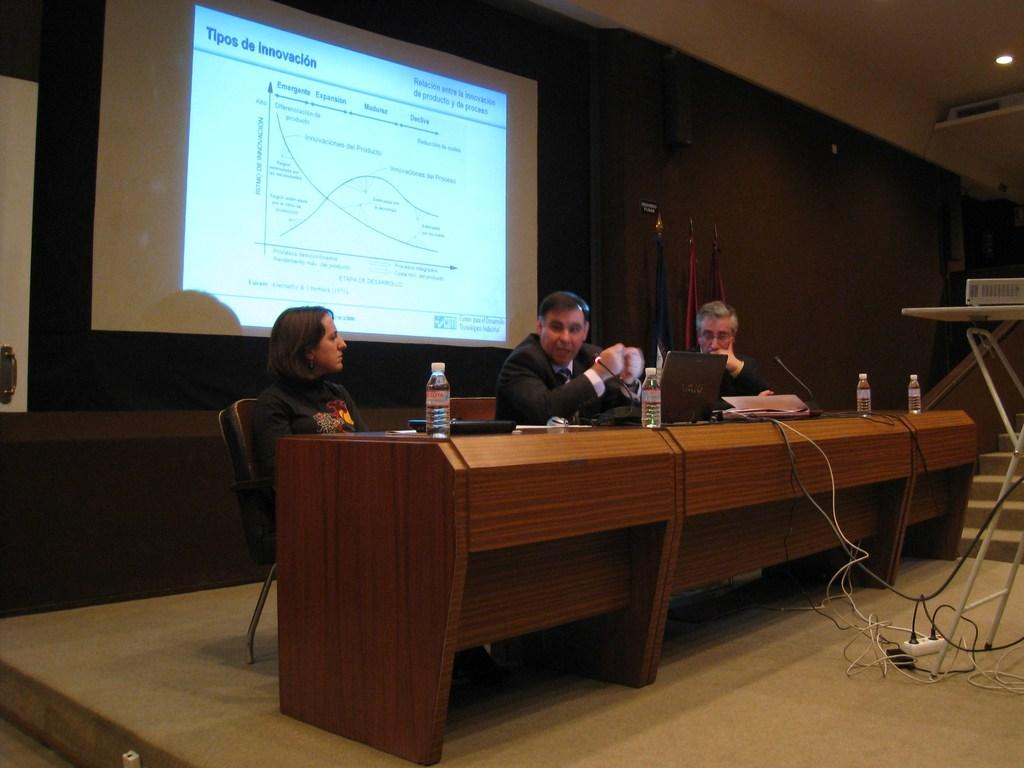What are the people in the image doing? The people in the image are sitting on chairs. What can be seen on the screen in the image? Unfortunately, the facts provided do not give any information about the content of the screen. Can you describe the setting where the people are sitting? Based on the facts provided, we cannot determine the setting where the people are sitting. What letter is being used to solve the arithmetic problem on the screen? There is no arithmetic problem or letter present on the screen in the image. How many bulbs are visible in the image? There is no mention of bulbs in the provided facts, so we cannot determine if any are visible in the image. 